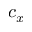Convert formula to latex. <formula><loc_0><loc_0><loc_500><loc_500>c _ { x }</formula> 